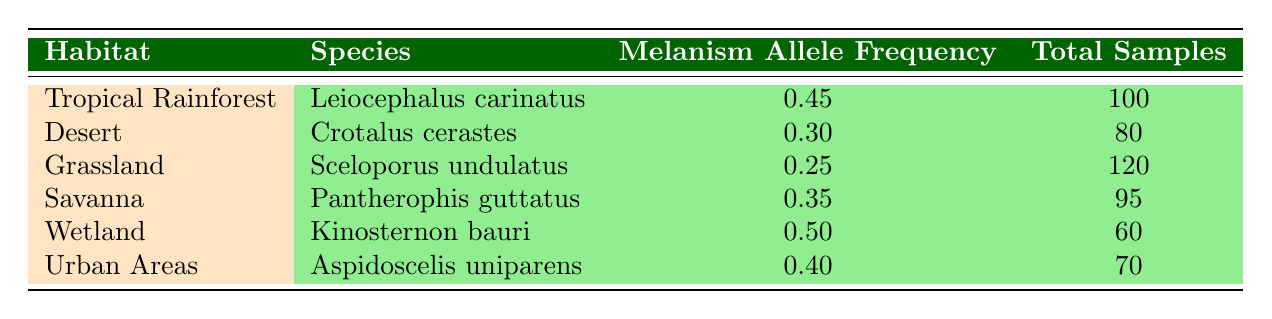What is the melanism allele frequency for Leiocephalus carinatus? The table lists the melanism allele frequency for Leiocephalus carinatus under the habitat Tropical Rainforest. It shows a frequency of 0.45.
Answer: 0.45 Which habitat has the highest melanism allele frequency? By comparing the melanism allele frequencies across all habitats in the table, Wetland has the highest frequency at 0.50.
Answer: Wetland What is the total number of samples taken from Sceloporus undulatus? The table states that Sceloporus undulatus has a total sample count listed as 120.
Answer: 120 Is the melanism allele frequency for Crotalus cerastes greater than 0.35? The frequency for Crotalus cerastes is 0.30, which is less than 0.35, making the statement false.
Answer: No What is the average melanism allele frequency across all habitats presented in the table? To find the average, we need to sum the frequencies: 0.45 + 0.30 + 0.25 + 0.35 + 0.50 + 0.40 = 2.25. There are 6 frequencies, so the average is 2.25 divided by 6, which equals 0.375.
Answer: 0.375 How many total samples were collected from the habitats with melanism allele frequencies greater than 0.4? The habitats with frequencies over 0.4 are Tropical Rainforest (100 samples), Wetland (60 samples), and Urban Areas (70 samples). Adding these gives: 100 + 60 + 70 = 230 samples in total.
Answer: 230 Which species has the lowest melanism allele frequency and what is that frequency? By analyzing the table, Sceloporus undulatus has the lowest melanism allele frequency at 0.25.
Answer: Sceloporus undulatus, 0.25 What is the difference in melanism allele frequency between the Wetland and Grassland habitats? The melanism frequency for Wetland is 0.50 and for Grassland it is 0.25. The difference is calculated as 0.50 - 0.25 = 0.25.
Answer: 0.25 